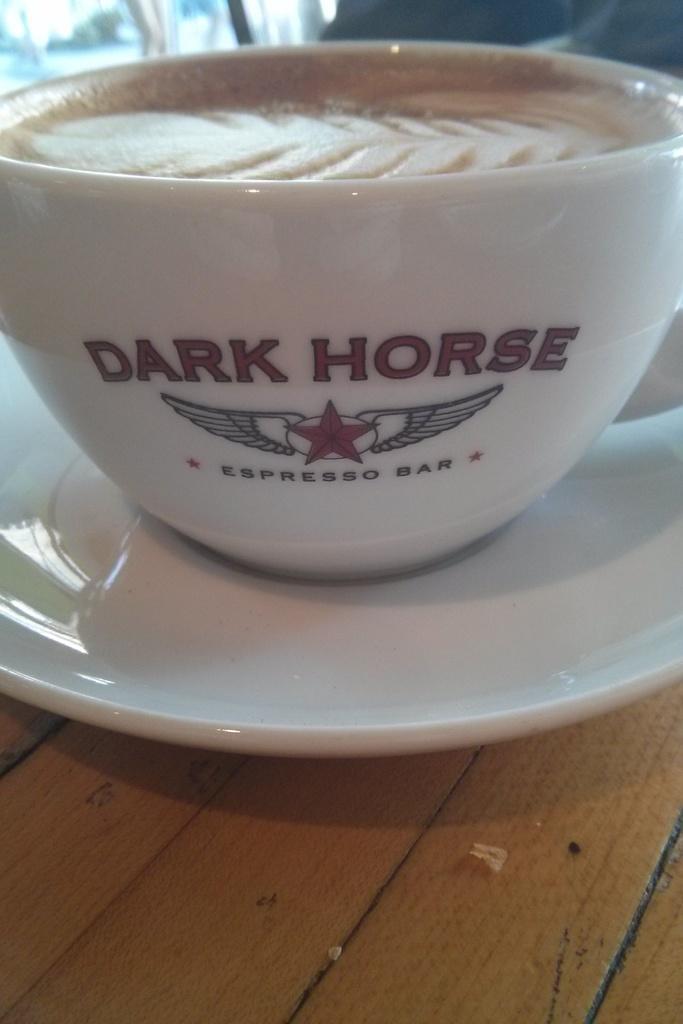Describe this image in one or two sentences. In this image I can see the cup and saucer. I can see these are in white color. The cup and saucer is on the brown color surface. 